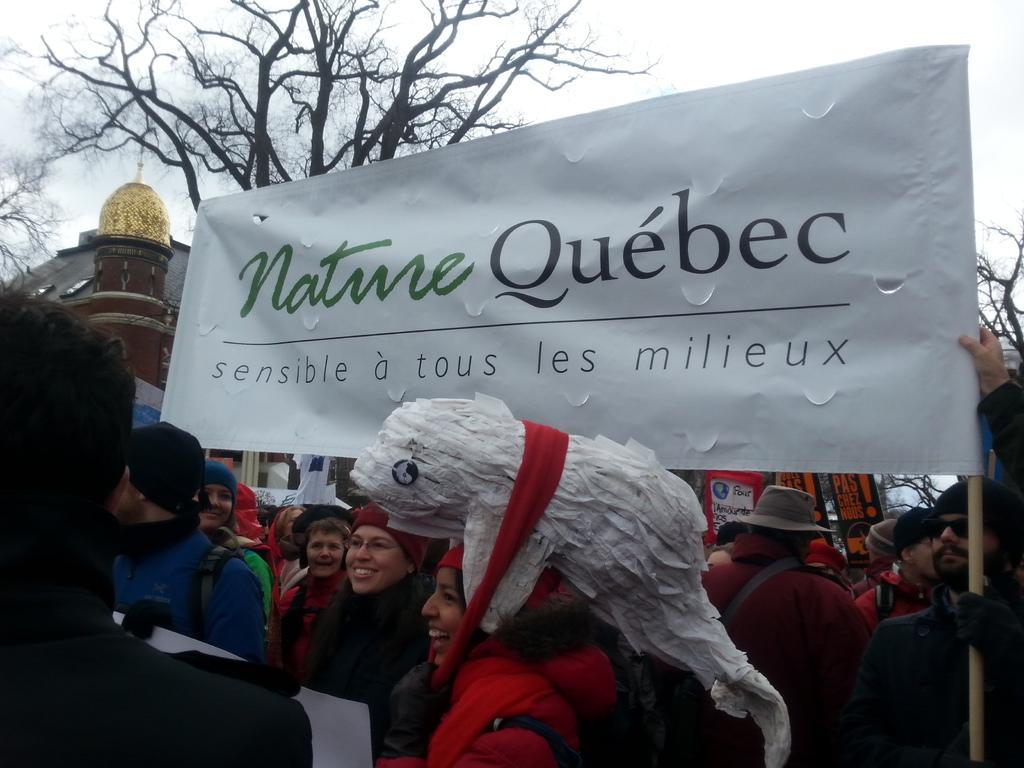Can you describe this image briefly? In this image, there are a few people, trees, houses and boards with text. We can also see a banner with some text. We can also see the sky and a white colored object. 